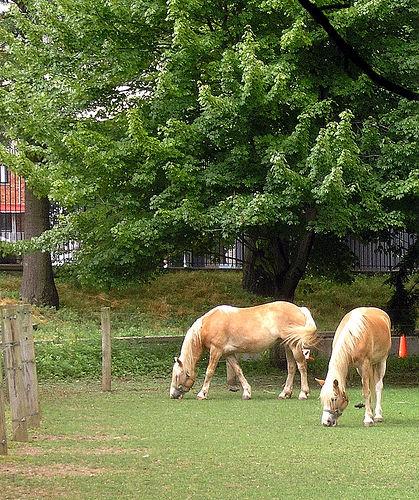How many horses are there?
Quick response, please. 2. What would you call these horse's hair color if they were human?
Quick response, please. Blonde. Is anyone riding these horses?
Write a very short answer. No. 